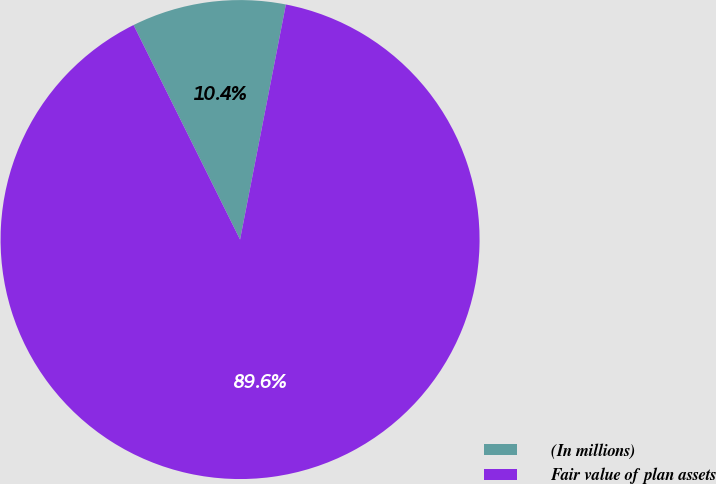<chart> <loc_0><loc_0><loc_500><loc_500><pie_chart><fcel>(In millions)<fcel>Fair value of plan assets<nl><fcel>10.4%<fcel>89.6%<nl></chart> 